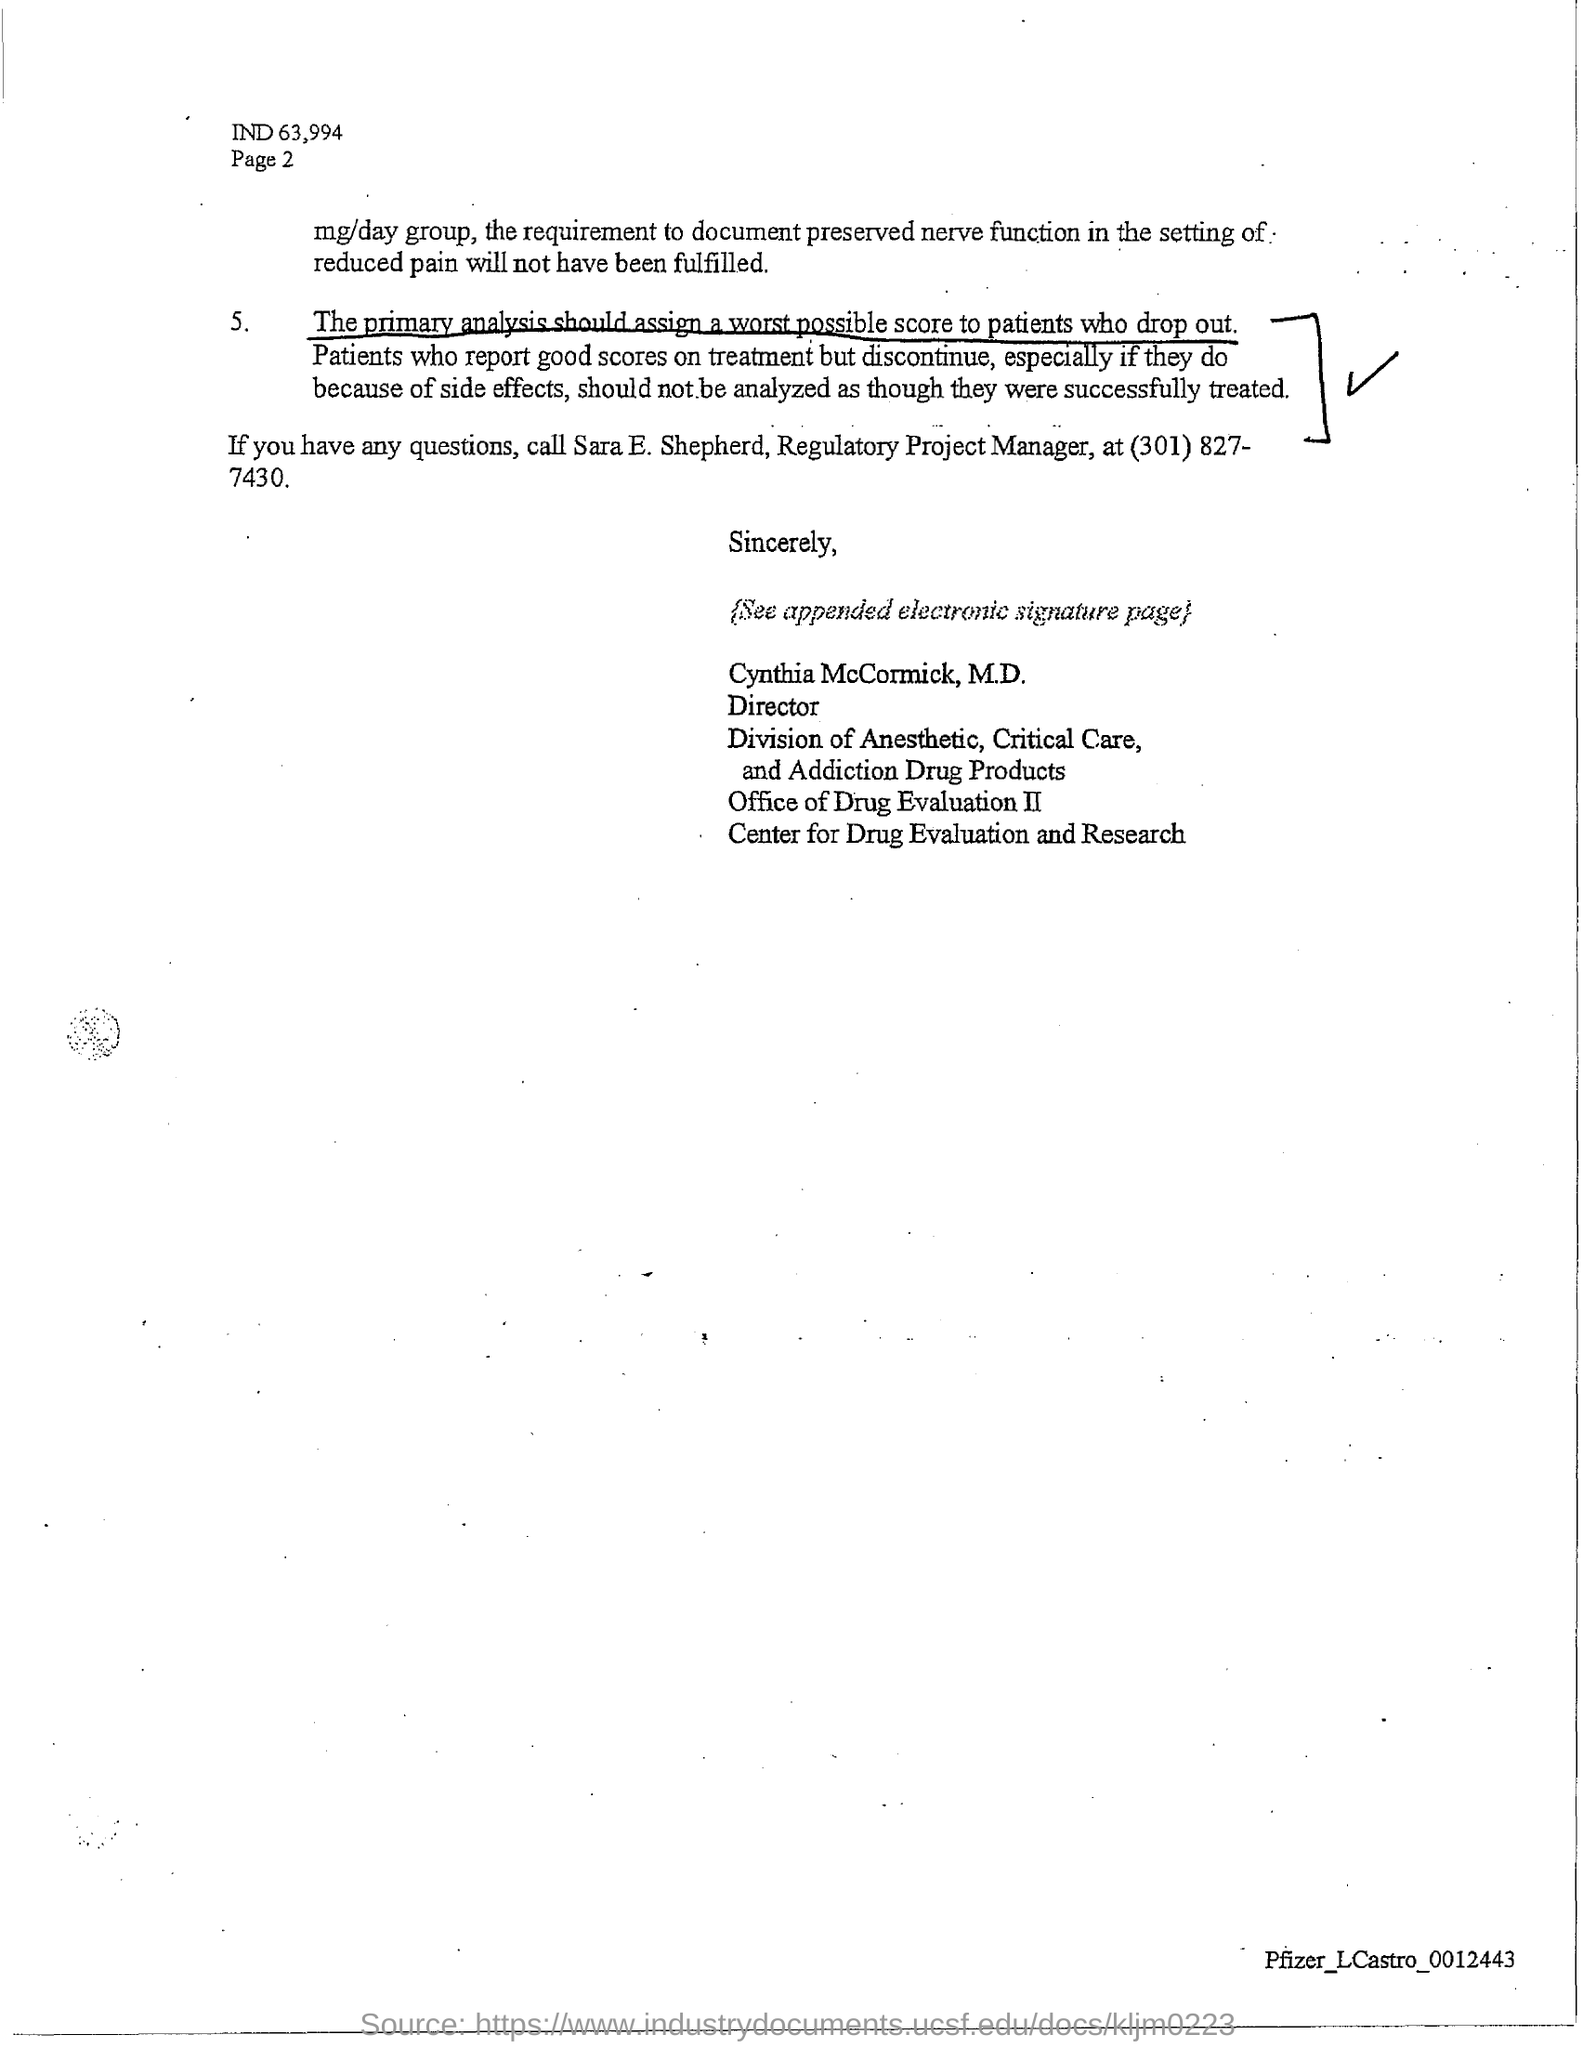Outline some significant characteristics in this image. Sara E. Shepherd holds the designation of Regulatory Project Manager. 